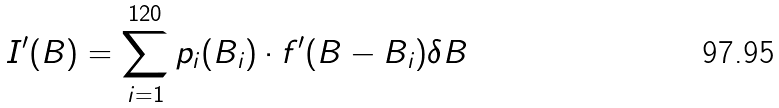<formula> <loc_0><loc_0><loc_500><loc_500>I ^ { \prime } ( B ) = \sum _ { i = 1 } ^ { 1 2 0 } p _ { i } ( B _ { i } ) \cdot f ^ { \prime } ( B - B _ { i } ) \delta B</formula> 